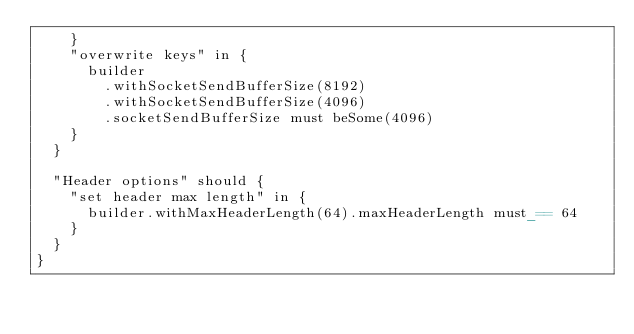Convert code to text. <code><loc_0><loc_0><loc_500><loc_500><_Scala_>    }
    "overwrite keys" in {
      builder
        .withSocketSendBufferSize(8192)
        .withSocketSendBufferSize(4096)
        .socketSendBufferSize must beSome(4096)
    }
  }

  "Header options" should {
    "set header max length" in {
      builder.withMaxHeaderLength(64).maxHeaderLength must_== 64
    }
  }
}
</code> 